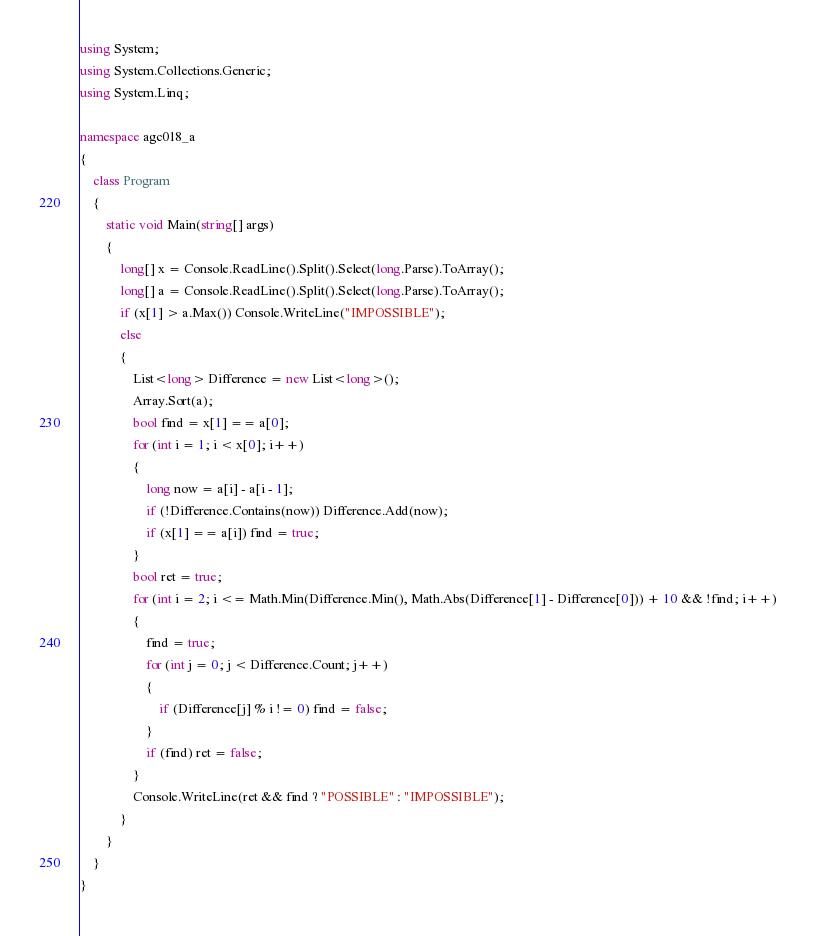Convert code to text. <code><loc_0><loc_0><loc_500><loc_500><_C#_>using System;
using System.Collections.Generic;
using System.Linq;

namespace agc018_a
{
    class Program
    {
        static void Main(string[] args)
        {
            long[] x = Console.ReadLine().Split().Select(long.Parse).ToArray();
            long[] a = Console.ReadLine().Split().Select(long.Parse).ToArray();
            if (x[1] > a.Max()) Console.WriteLine("IMPOSSIBLE");
            else
            {
                List<long> Difference = new List<long>();
                Array.Sort(a);
                bool find = x[1] == a[0];
                for (int i = 1; i < x[0]; i++)
                {
                    long now = a[i] - a[i - 1];
                    if (!Difference.Contains(now)) Difference.Add(now);
                    if (x[1] == a[i]) find = true;
                }
                bool ret = true;
                for (int i = 2; i <= Math.Min(Difference.Min(), Math.Abs(Difference[1] - Difference[0])) + 10 && !find; i++)
                {
                    find = true;
                    for (int j = 0; j < Difference.Count; j++)
                    {
                        if (Difference[j] % i != 0) find = false;
                    }
                    if (find) ret = false;
                }
                Console.WriteLine(ret && find ? "POSSIBLE" : "IMPOSSIBLE");
            }
        }
    }
}</code> 